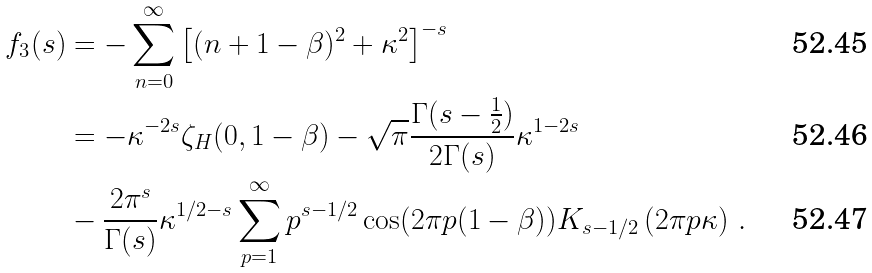<formula> <loc_0><loc_0><loc_500><loc_500>f _ { 3 } ( s ) & = - \sum _ { n = 0 } ^ { \infty } \left [ ( n + 1 - \beta ) ^ { 2 } + \kappa ^ { 2 } \right ] ^ { - s } \\ & = - \kappa ^ { - 2 s } \zeta _ { H } ( 0 , 1 - \beta ) - \sqrt { \pi } \frac { \Gamma ( s - \frac { 1 } { 2 } ) } { 2 \Gamma ( s ) } \kappa ^ { 1 - 2 s } \\ & - \frac { 2 \pi ^ { s } } { \Gamma ( s ) } \kappa ^ { 1 / 2 - s } \sum _ { p = 1 } ^ { \infty } p ^ { s - 1 / 2 } \cos ( 2 \pi p ( 1 - \beta ) ) K _ { s - 1 / 2 } \left ( 2 \pi p \kappa \right ) \, .</formula> 